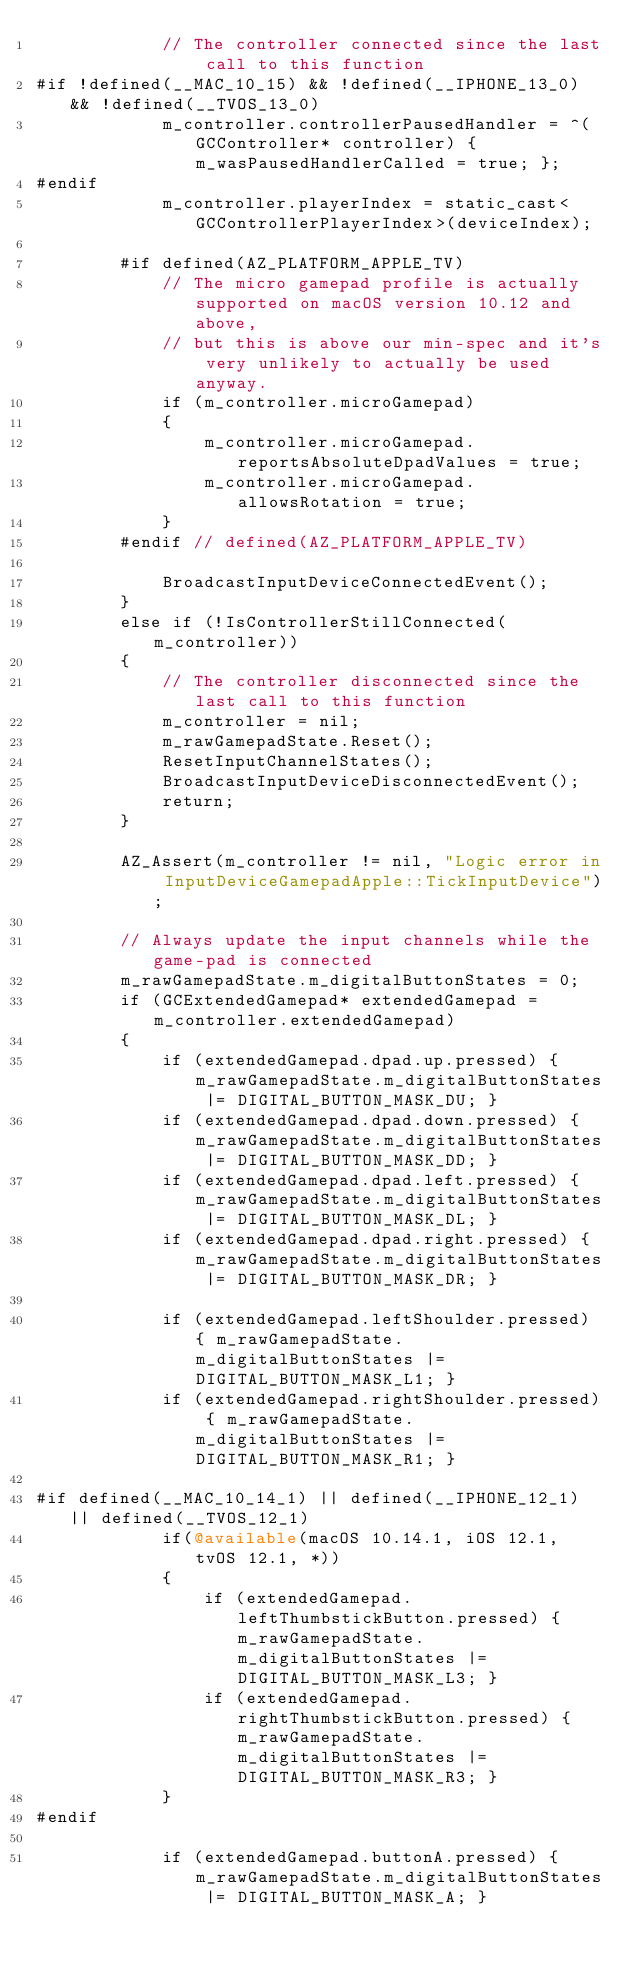Convert code to text. <code><loc_0><loc_0><loc_500><loc_500><_ObjectiveC_>            // The controller connected since the last call to this function
#if !defined(__MAC_10_15) && !defined(__IPHONE_13_0) && !defined(__TVOS_13_0)
            m_controller.controllerPausedHandler = ^(GCController* controller) { m_wasPausedHandlerCalled = true; };
#endif
            m_controller.playerIndex = static_cast<GCControllerPlayerIndex>(deviceIndex);

        #if defined(AZ_PLATFORM_APPLE_TV)
            // The micro gamepad profile is actually supported on macOS version 10.12 and above,
            // but this is above our min-spec and it's very unlikely to actually be used anyway.
            if (m_controller.microGamepad)
            {
                m_controller.microGamepad.reportsAbsoluteDpadValues = true;
                m_controller.microGamepad.allowsRotation = true;
            }
        #endif // defined(AZ_PLATFORM_APPLE_TV)

            BroadcastInputDeviceConnectedEvent();
        }
        else if (!IsControllerStillConnected(m_controller))
        {
            // The controller disconnected since the last call to this function
            m_controller = nil;
            m_rawGamepadState.Reset();
            ResetInputChannelStates();
            BroadcastInputDeviceDisconnectedEvent();
            return;
        }

        AZ_Assert(m_controller != nil, "Logic error in InputDeviceGamepadApple::TickInputDevice");

        // Always update the input channels while the game-pad is connected
        m_rawGamepadState.m_digitalButtonStates = 0;
        if (GCExtendedGamepad* extendedGamepad = m_controller.extendedGamepad)
        {
            if (extendedGamepad.dpad.up.pressed) { m_rawGamepadState.m_digitalButtonStates |= DIGITAL_BUTTON_MASK_DU; }
            if (extendedGamepad.dpad.down.pressed) { m_rawGamepadState.m_digitalButtonStates |= DIGITAL_BUTTON_MASK_DD; }
            if (extendedGamepad.dpad.left.pressed) { m_rawGamepadState.m_digitalButtonStates |= DIGITAL_BUTTON_MASK_DL; }
            if (extendedGamepad.dpad.right.pressed) { m_rawGamepadState.m_digitalButtonStates |= DIGITAL_BUTTON_MASK_DR; }

            if (extendedGamepad.leftShoulder.pressed) { m_rawGamepadState.m_digitalButtonStates |= DIGITAL_BUTTON_MASK_L1; }
            if (extendedGamepad.rightShoulder.pressed) { m_rawGamepadState.m_digitalButtonStates |= DIGITAL_BUTTON_MASK_R1; }
            
#if defined(__MAC_10_14_1) || defined(__IPHONE_12_1) || defined(__TVOS_12_1)
            if(@available(macOS 10.14.1, iOS 12.1, tvOS 12.1, *))
            {
                if (extendedGamepad.leftThumbstickButton.pressed) { m_rawGamepadState.m_digitalButtonStates |= DIGITAL_BUTTON_MASK_L3; }
                if (extendedGamepad.rightThumbstickButton.pressed) { m_rawGamepadState.m_digitalButtonStates |= DIGITAL_BUTTON_MASK_R3; }
            }
#endif
            
            if (extendedGamepad.buttonA.pressed) { m_rawGamepadState.m_digitalButtonStates |= DIGITAL_BUTTON_MASK_A; }</code> 